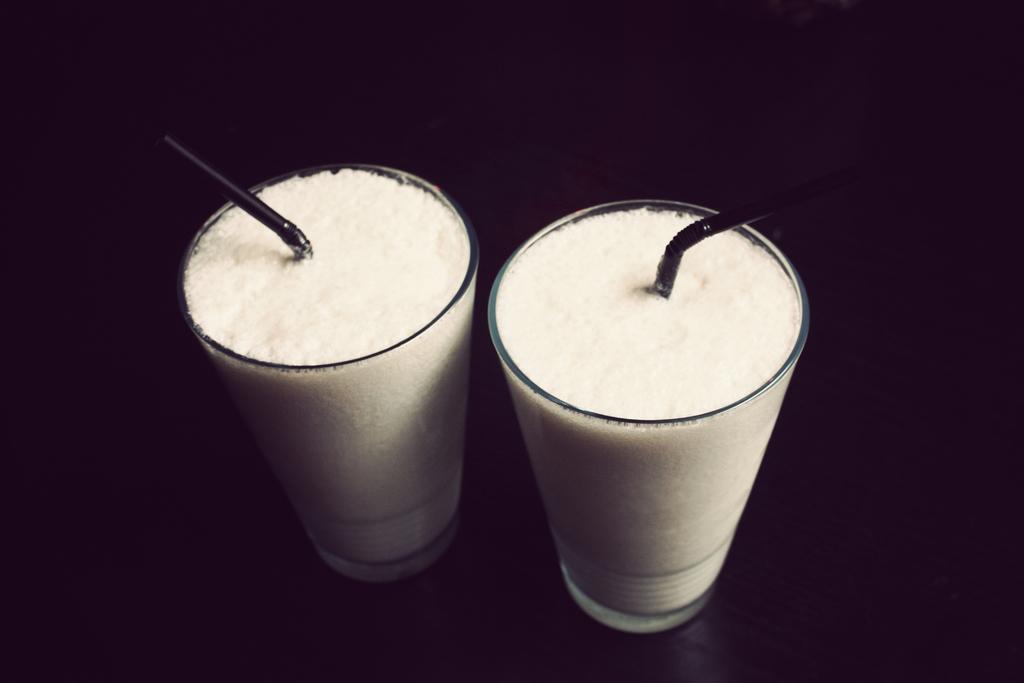In one or two sentences, can you explain what this image depicts? In this image we can see two glasses with straws on the black surface. 